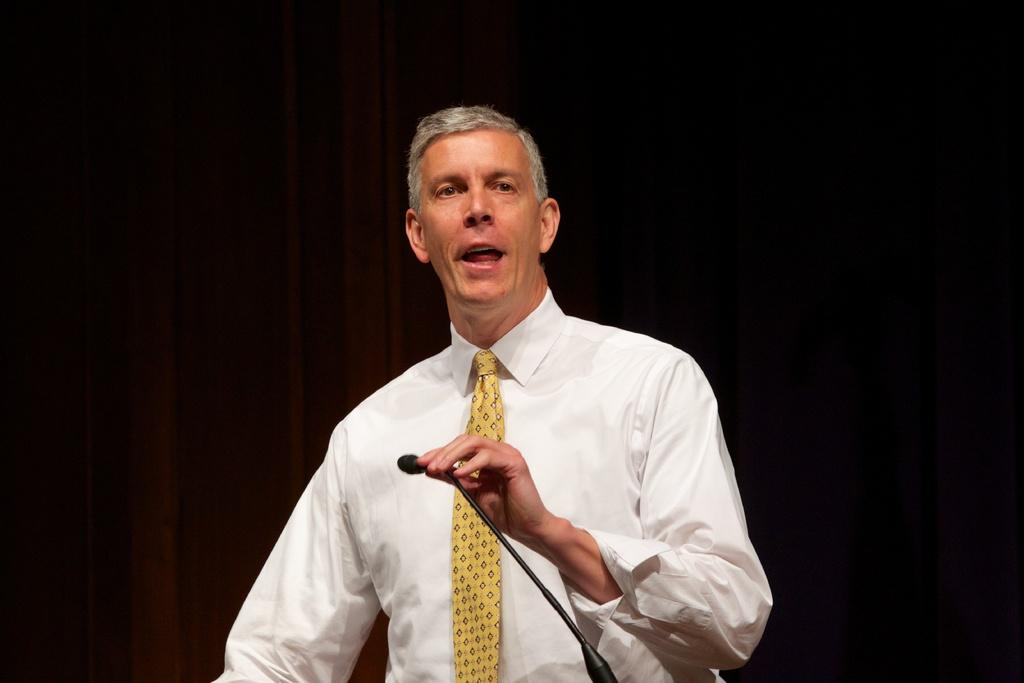Who is the main subject in the image? There is a man in the image. What is the man wearing? The man is wearing a white shirt. What object is in front of the man? There is a microphone in front of the man. What type of seat is the man sitting on in the image? There is no seat present in the image; the man is standing. 